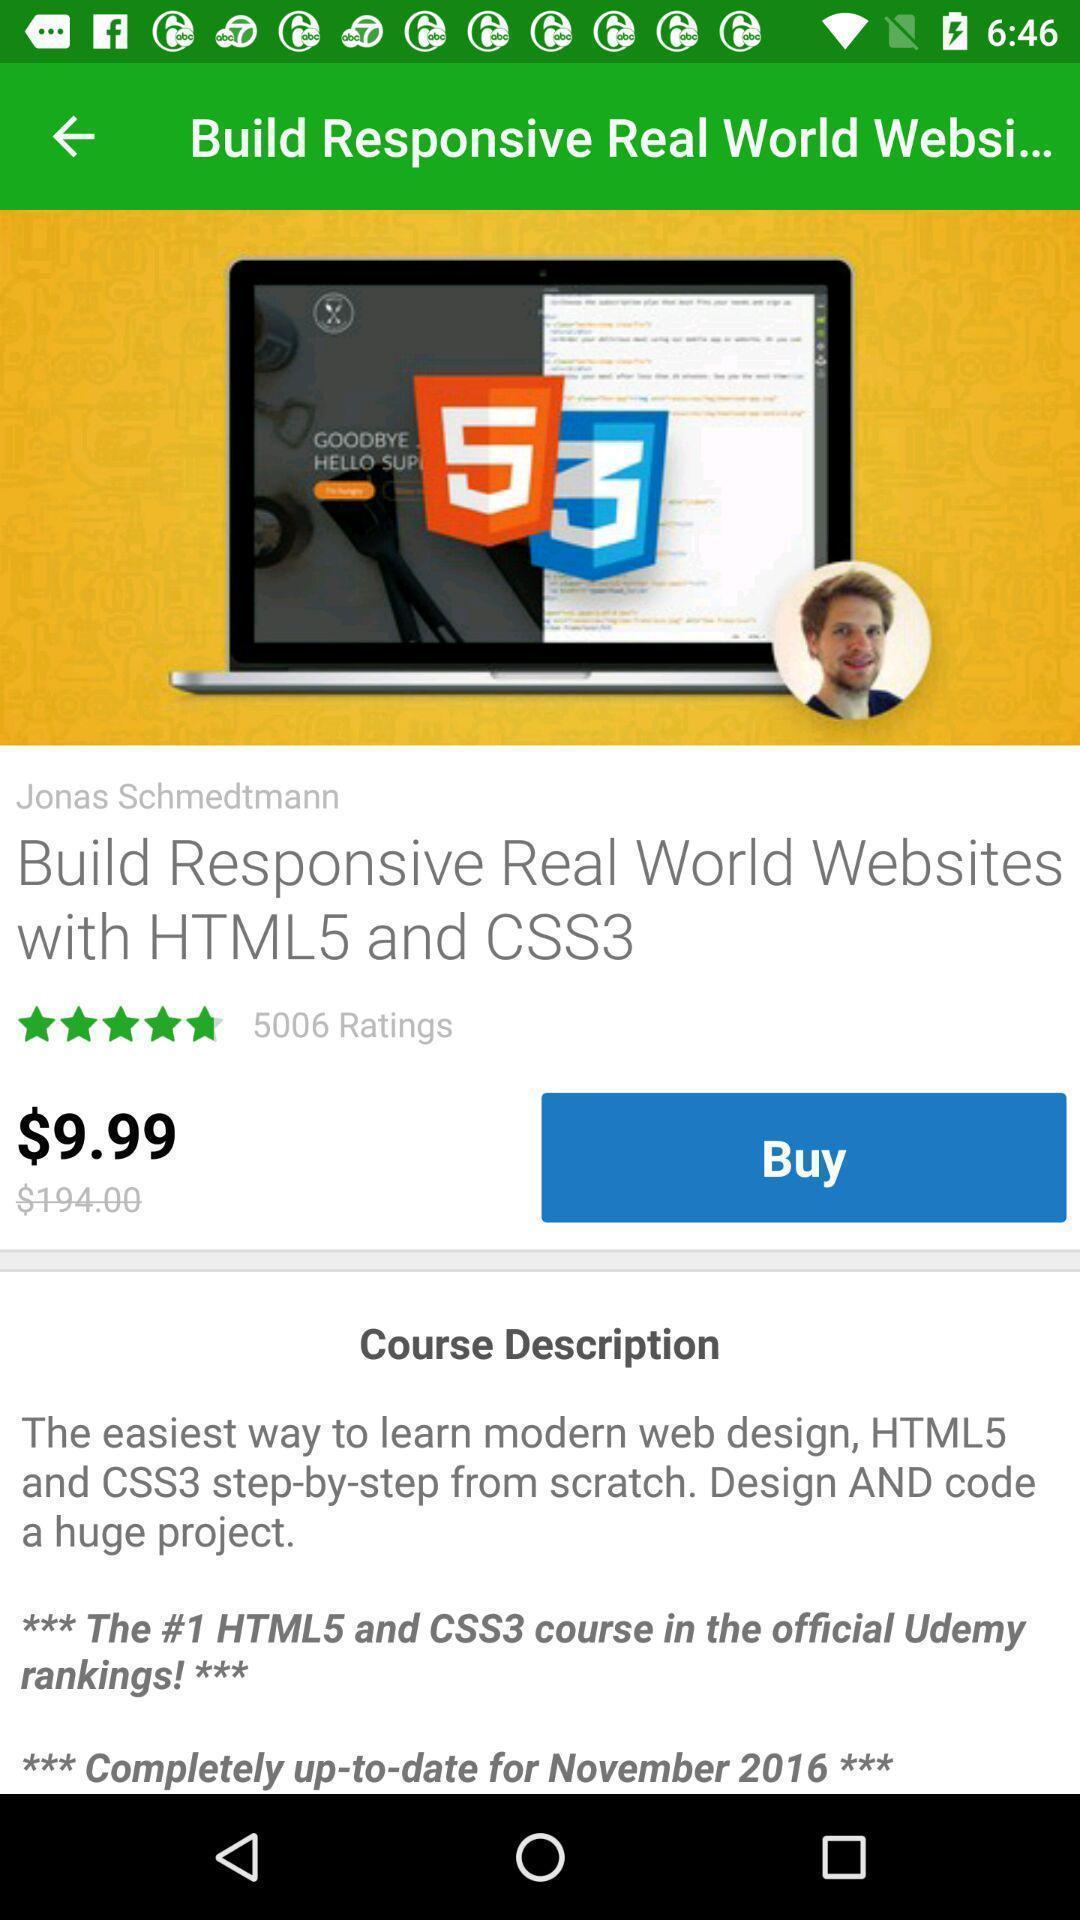Provide a detailed account of this screenshot. Screen shows to buy an application. 